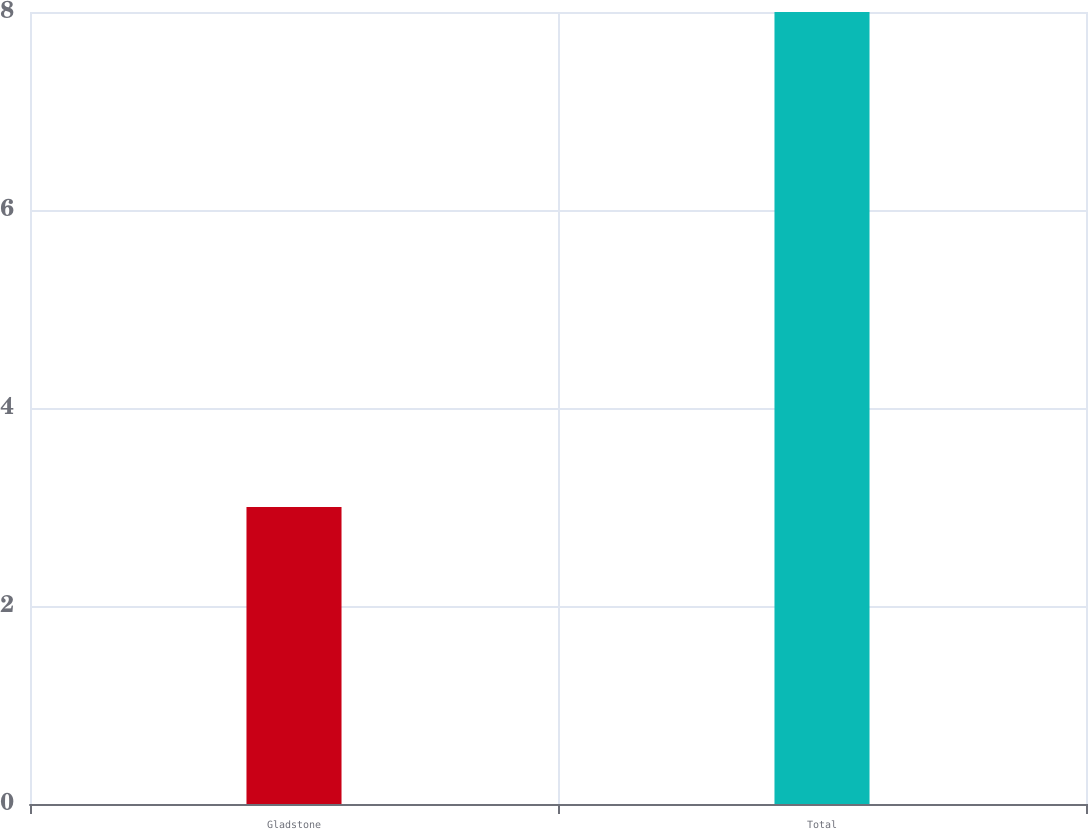Convert chart. <chart><loc_0><loc_0><loc_500><loc_500><bar_chart><fcel>Gladstone<fcel>Total<nl><fcel>3<fcel>8<nl></chart> 